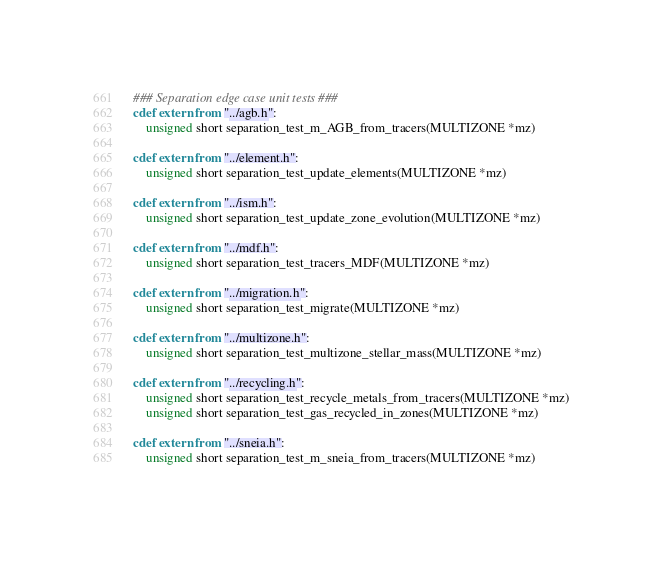Convert code to text. <code><loc_0><loc_0><loc_500><loc_500><_Cython_>### Separation edge case unit tests ### 
cdef extern from "../agb.h": 
	unsigned short separation_test_m_AGB_from_tracers(MULTIZONE *mz) 

cdef extern from "../element.h": 
	unsigned short separation_test_update_elements(MULTIZONE *mz) 

cdef extern from "../ism.h": 
	unsigned short separation_test_update_zone_evolution(MULTIZONE *mz) 

cdef extern from "../mdf.h": 
	unsigned short separation_test_tracers_MDF(MULTIZONE *mz) 

cdef extern from "../migration.h": 
	unsigned short separation_test_migrate(MULTIZONE *mz) 

cdef extern from "../multizone.h": 
	unsigned short separation_test_multizone_stellar_mass(MULTIZONE *mz) 

cdef extern from "../recycling.h": 
	unsigned short separation_test_recycle_metals_from_tracers(MULTIZONE *mz) 
	unsigned short separation_test_gas_recycled_in_zones(MULTIZONE *mz) 

cdef extern from "../sneia.h": 
	unsigned short separation_test_m_sneia_from_tracers(MULTIZONE *mz) 

</code> 